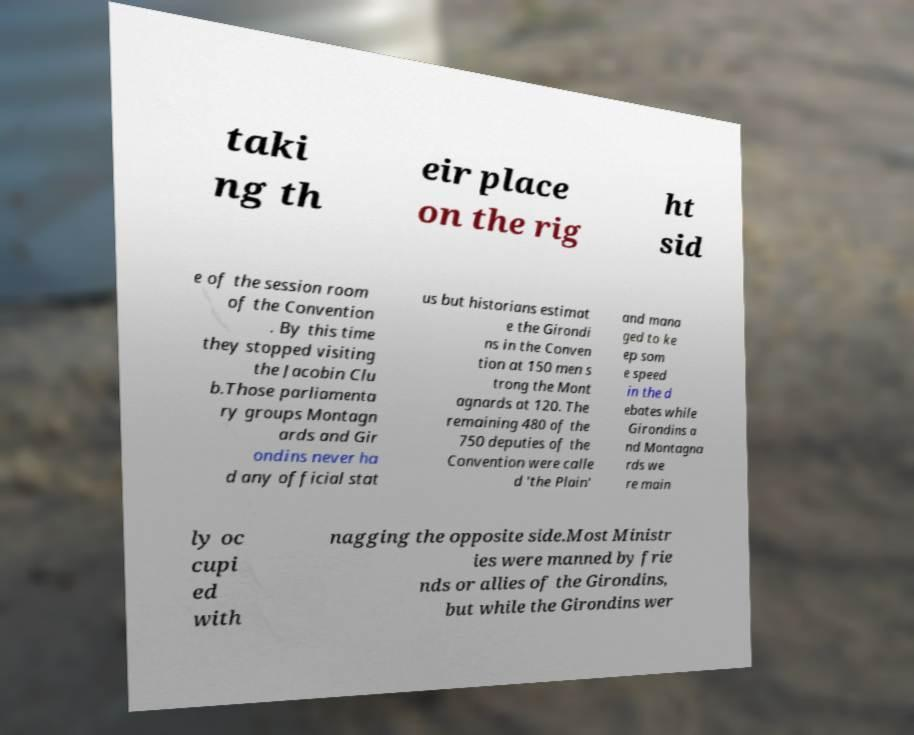There's text embedded in this image that I need extracted. Can you transcribe it verbatim? taki ng th eir place on the rig ht sid e of the session room of the Convention . By this time they stopped visiting the Jacobin Clu b.Those parliamenta ry groups Montagn ards and Gir ondins never ha d any official stat us but historians estimat e the Girondi ns in the Conven tion at 150 men s trong the Mont agnards at 120. The remaining 480 of the 750 deputies of the Convention were calle d 'the Plain' and mana ged to ke ep som e speed in the d ebates while Girondins a nd Montagna rds we re main ly oc cupi ed with nagging the opposite side.Most Ministr ies were manned by frie nds or allies of the Girondins, but while the Girondins wer 